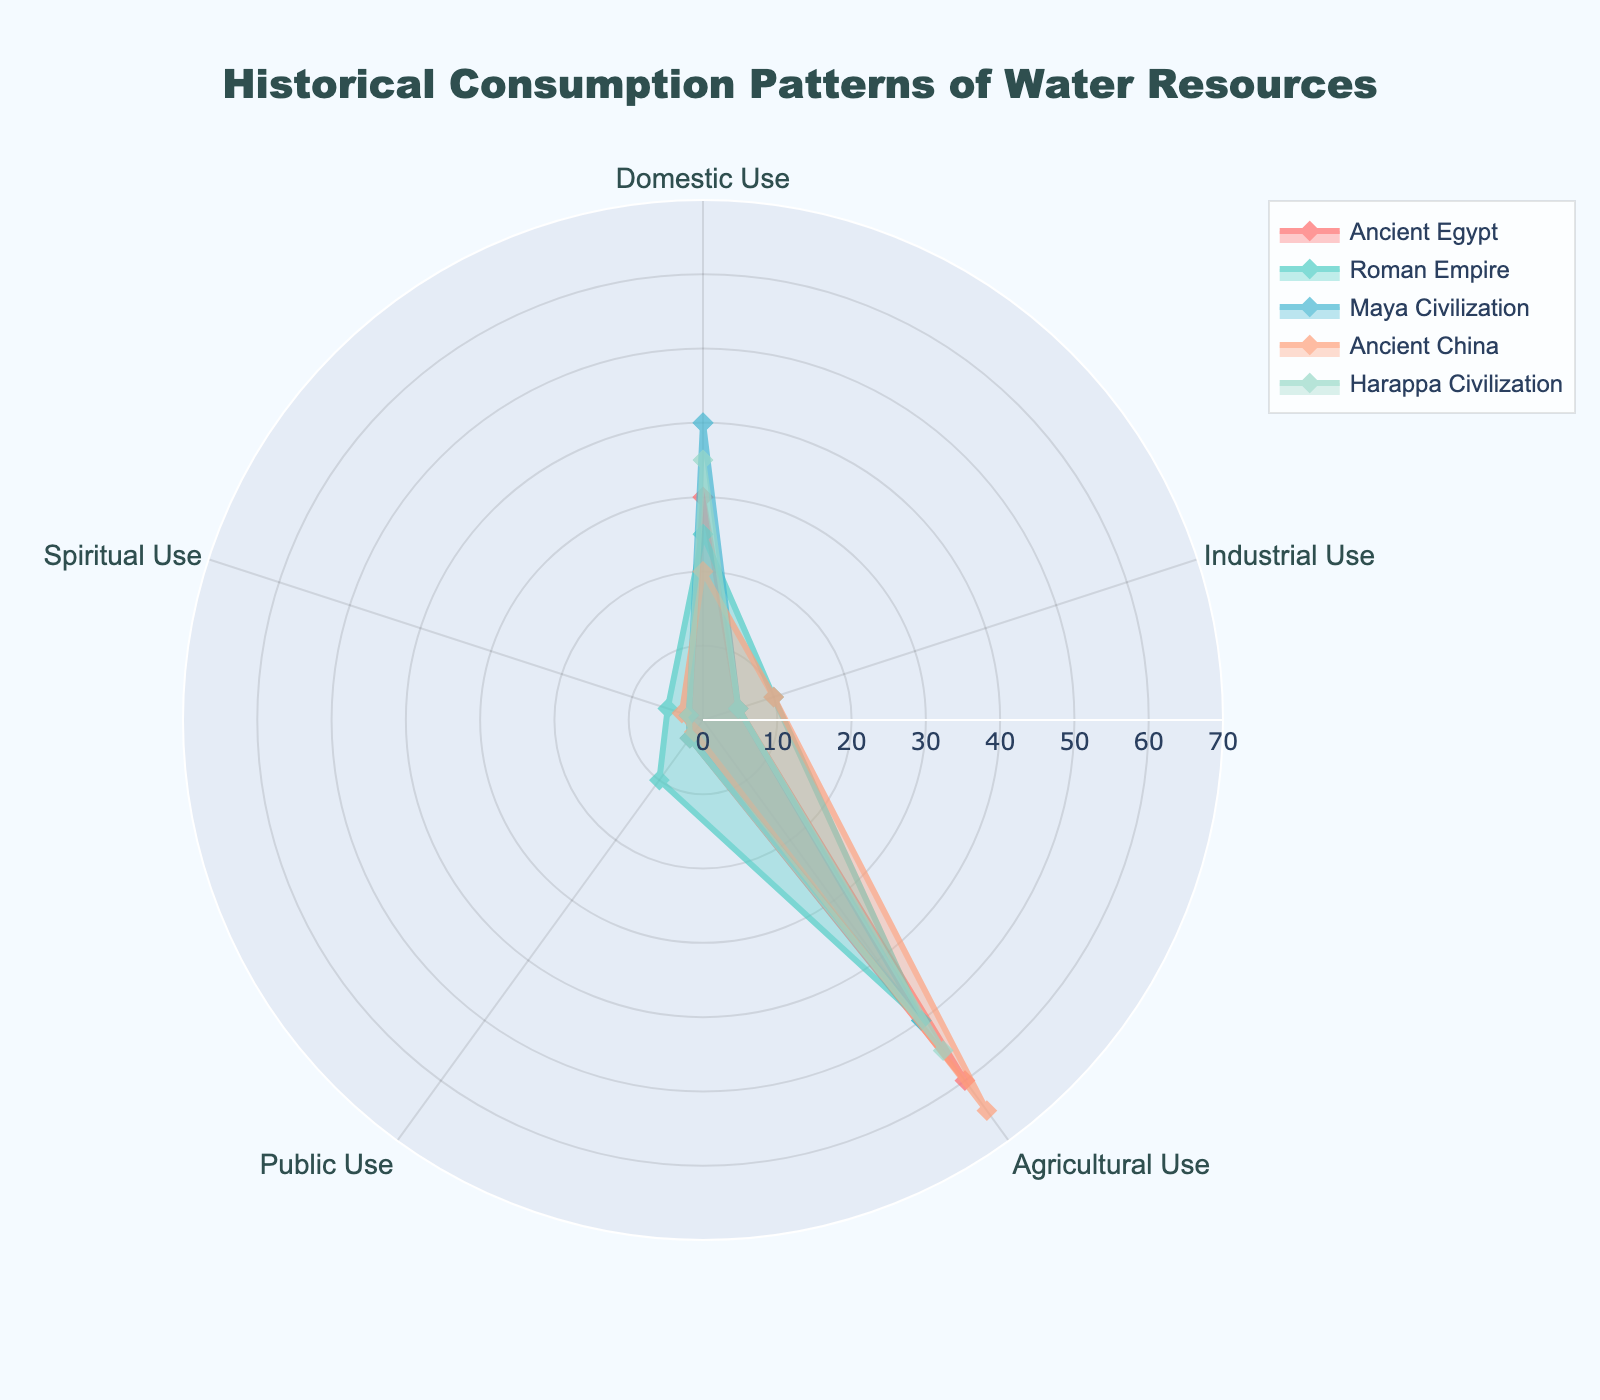what's the title of the chart? The title is displayed at the top of the chart within the plot layout. It provides a summary of the chart's content.
Answer: Historical Consumption Patterns of Water Resources which civilization has the highest domestic use of water? By comparing the plotted points for "Domestic Use" across the different civilizations, we find that the Maya Civilization has the highest value.
Answer: Maya Civilization what is the combined value of Agricultural Use and Industrial Use for Ancient China? The value for Agricultural Use is 65 and for Industrial Use is 10. Adding these together: 65 + 10 = 75.
Answer: 75 which civilization has the lowest Public Use of water resources? By inspecting the data for "Public Use" across civilizations, we see that both Ancient China and Maya Civilization have the lowest with a value of 2.
Answer: Ancient China and Maya Civilization compare the Agricultural Use of Ancient Egypt and Harappa Civilization. Which civilization uses more, and by how much? Ancient Egypt has an Agricultural Use value of 60, while Harappa Civilization has a value of 55. The difference is 60 - 55 = 5, with Ancient Egypt using more.
Answer: Ancient Egypt, by 5 units which water use category shows the highest variation among the civilizations? By examining the range of values for each category, "Agricultural Use" shows the highest variation with values ranging from 50 to 65.
Answer: Agricultural Use compare the total water resources consumption (sum of all uses) between the Roman Empire and Ancient China. Which has a higher total? Summing the values for the Roman Empire: 25 + 10 + 50 + 10 + 5 = 100. Summing the values for Ancient China: 20 + 10 + 65 + 2 + 3 = 100. Both have the same total.
Answer: Both have the same total what is the range of Domestic Use values across all the civilizations? The smallest value is 20 (Ancient China) and the highest is 40 (Maya Civilization). The range is 40 - 20 = 20.
Answer: 20 which civilization dedicates 10% or more of their total water use to Industrial Use? To determine this, we calculate 10% of the total water use for each civilization. Both the Roman Empire (10/100) and Ancient China (10/100) dedicate 10% to Industrial Use.
Answer: Roman Empire and Ancient China what is the average Public Use value across all civilizations? Sum the Public Use values: 3 (Egypt) + 10 (Rome) + 3 (Maya) + 2 (China) + 3 (Harappa) = 21 and divide by the number of civilizations (5): 21 / 5 = 4.2.
Answer: 4.2 